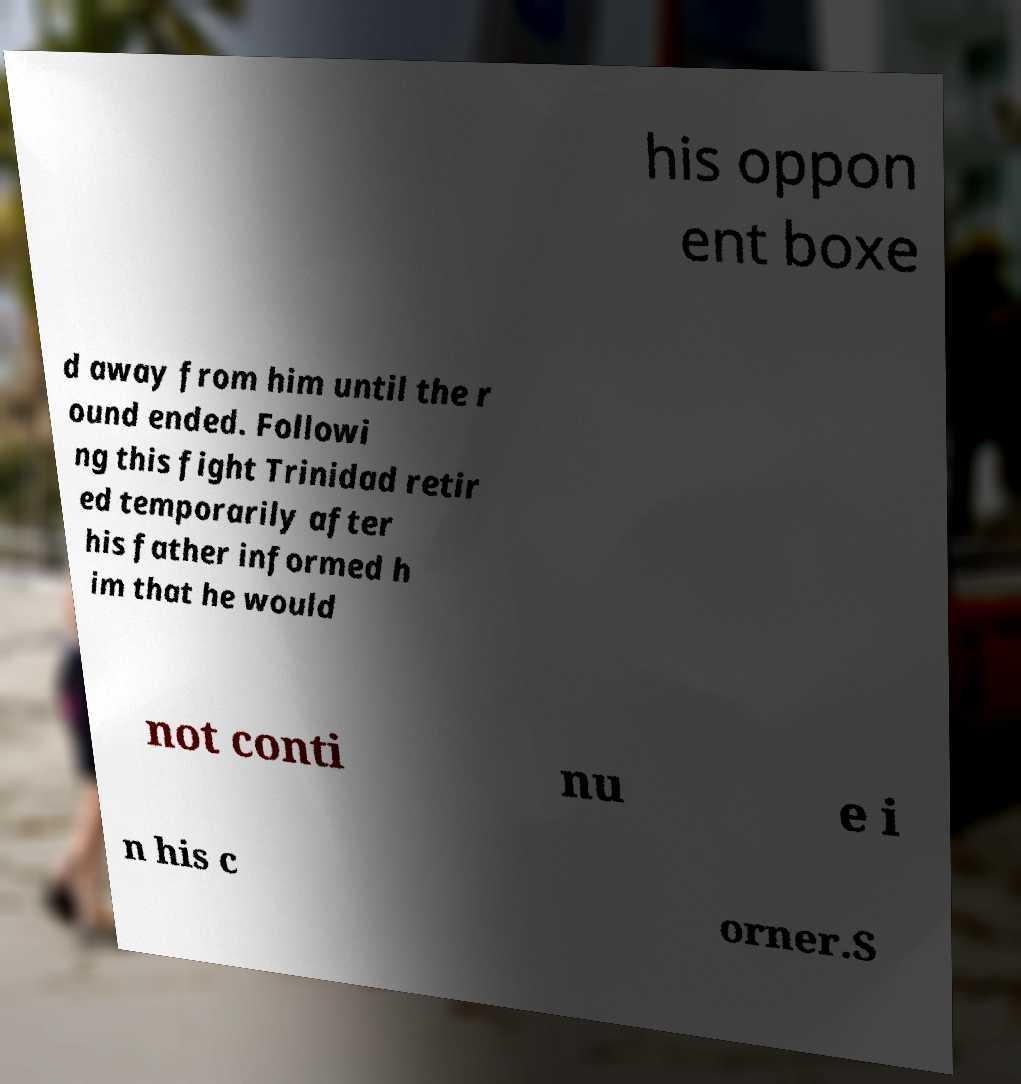I need the written content from this picture converted into text. Can you do that? his oppon ent boxe d away from him until the r ound ended. Followi ng this fight Trinidad retir ed temporarily after his father informed h im that he would not conti nu e i n his c orner.S 